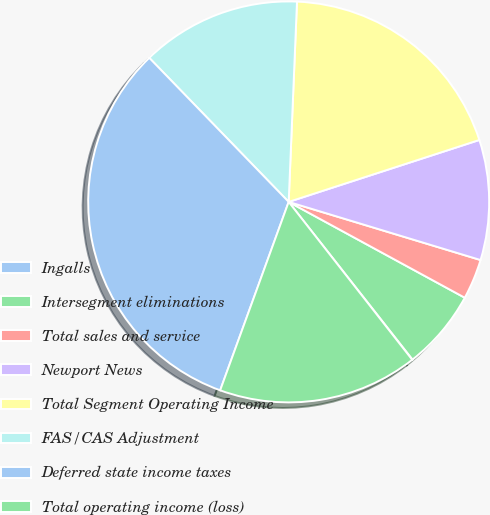Convert chart. <chart><loc_0><loc_0><loc_500><loc_500><pie_chart><fcel>Ingalls<fcel>Intersegment eliminations<fcel>Total sales and service<fcel>Newport News<fcel>Total Segment Operating Income<fcel>FAS/CAS Adjustment<fcel>Deferred state income taxes<fcel>Total operating income (loss)<nl><fcel>0.03%<fcel>6.47%<fcel>3.25%<fcel>9.68%<fcel>19.34%<fcel>12.9%<fcel>32.21%<fcel>16.12%<nl></chart> 